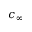Convert formula to latex. <formula><loc_0><loc_0><loc_500><loc_500>c _ { \infty }</formula> 